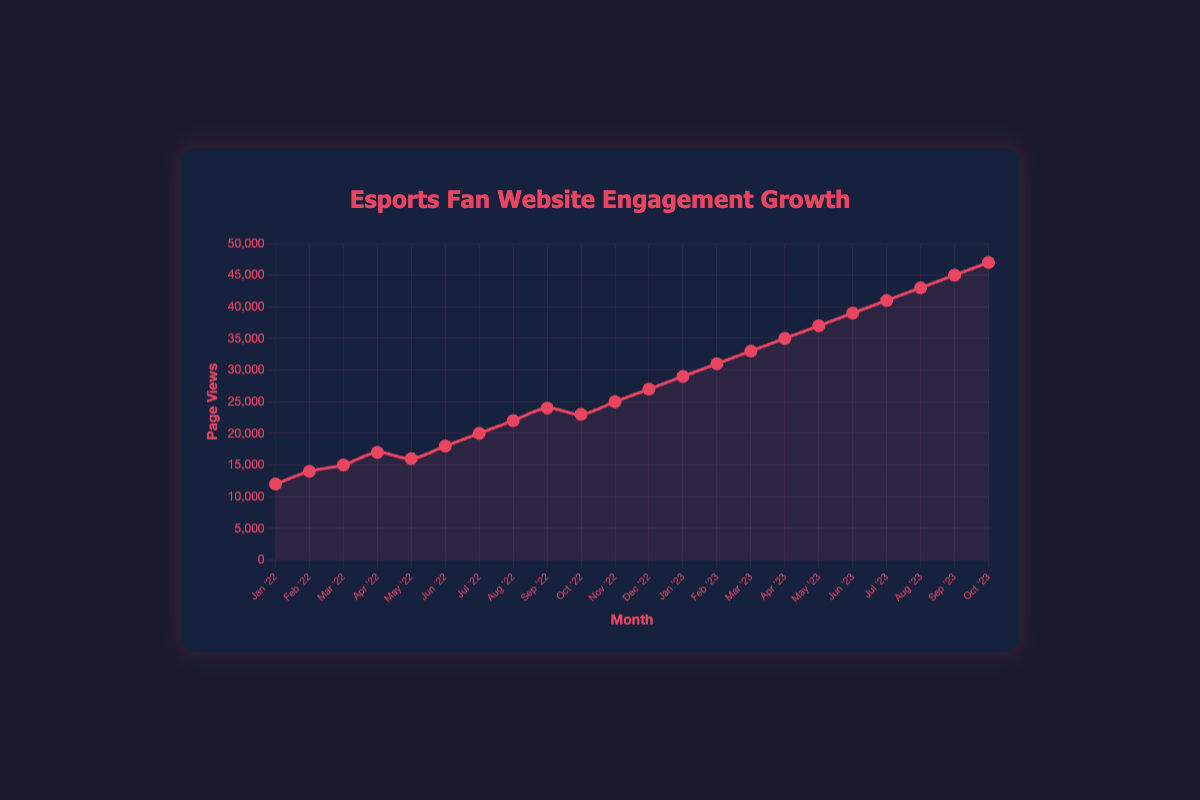What is the total increase in monthly page views from January 2022 to October 2023? The page views in January 2022 were 12,000, and in October 2023, they were 47,000. The increase is 47,000 - 12,000 = 35,000.
Answer: 35,000 Which month in 2022 had the highest increase in page views over the previous month? The page views increased by the following amounts: February: 2,000, March: 1,000, April: 2,000, May: -1,000, June: 2,000, July: 2,000, August: 2,000, September: 2,000, October: -1,000, November: 2,000, December: 2,000. The highest increase was in April with an increase of 2,000 views over March.
Answer: April 2022 How many months in 2023 saw an increase in page views over the previous month? Looking at the monthly increments in 2023: January: 2,000, February: 2,000, March: 2,000, April: 2,000, May: 2,000, June: 2,000, July: 2,000, August: 2,000, September: 2,000, October: 2,000, all months in 2023 saw an increase. There are 10 months from January to October.
Answer: 10 What is the average monthly page views for the period from January 2022 to October 2022? Total page views from January 2022 to October 2022 are 12000 + 14000 + 15000 + 17000 + 16000 + 18000 + 20000 + 22000 + 24000 + 23000 = 181000. There are 10 months in this period. The average monthly page views is 181000 / 10 = 18100.
Answer: 18,100 Compare the page views in June 2022 and June 2023, which month had higher page views? June 2022 had 18,000 page views and June 2023 had 39,000 page views. June 2023 had higher page views.
Answer: June 2023 What is the page views growth rate from January 2022 to January 2023? January 2022 had 12,000 page views and January 2023 had 29,000 page views. The growth rate = ((29000 - 12000) / 12000) * 100% = 141.67%.
Answer: 141.67% Which months in 2022 had page views less than 20,000? The following months had page views less than 20,000: January (12,000), February (14,000), March (15,000), April (17,000), May (16,000), June (18,000).
Answer: January, February, March, April, May, June By how many page views did the fan website grow from August 2022 to October 2023? August 2022 had 22,000 page views, and October 2023 had 47,000 page views. The growth is 47,000 - 22,000 = 25,000 page views.
Answer: 25,000 